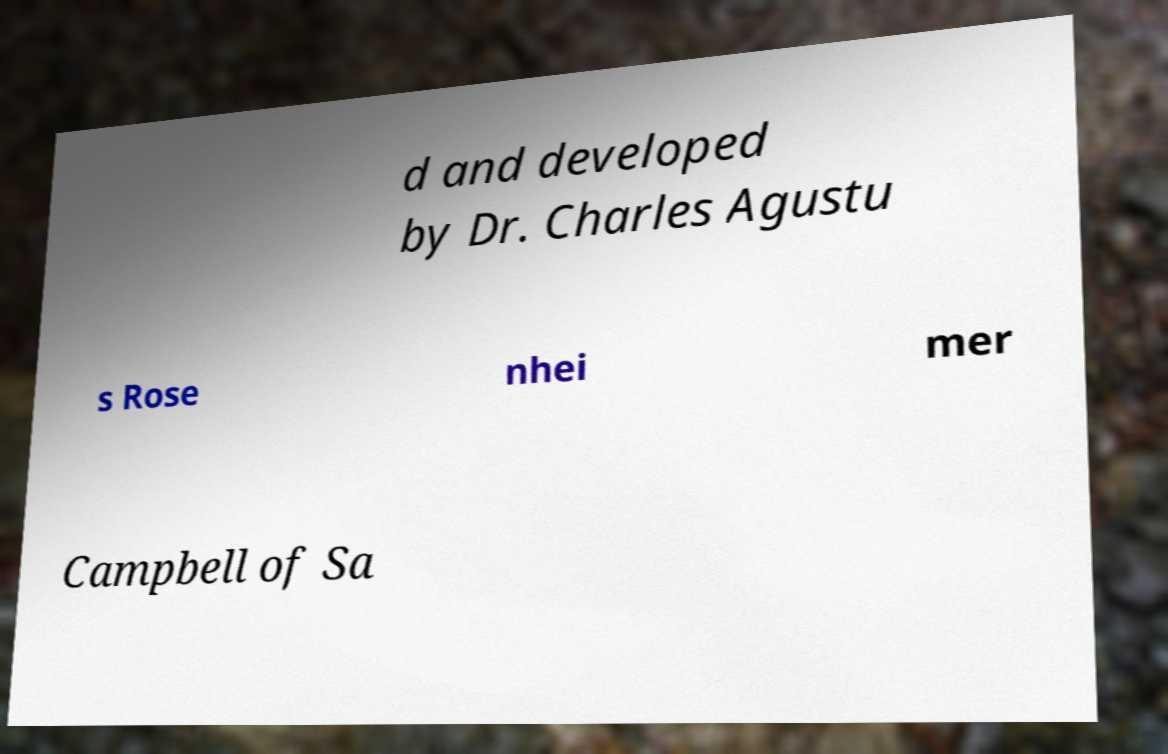I need the written content from this picture converted into text. Can you do that? d and developed by Dr. Charles Agustu s Rose nhei mer Campbell of Sa 